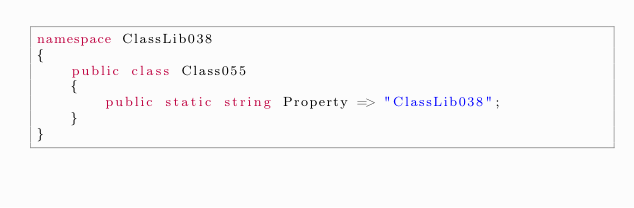<code> <loc_0><loc_0><loc_500><loc_500><_C#_>namespace ClassLib038
{
    public class Class055
    {
        public static string Property => "ClassLib038";
    }
}
</code> 